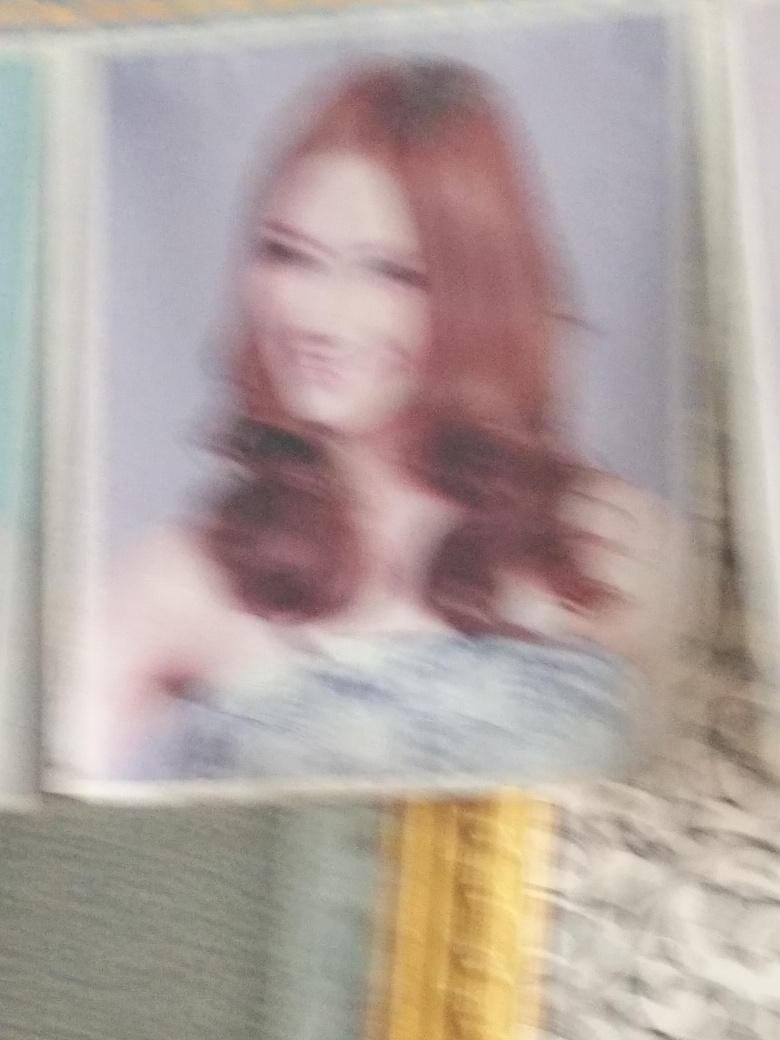What is the overall quality of this image?
A. Average
B. Very poor
C. Good
D. Excellent
Answer with the option's letter from the given choices directly.
 B. 